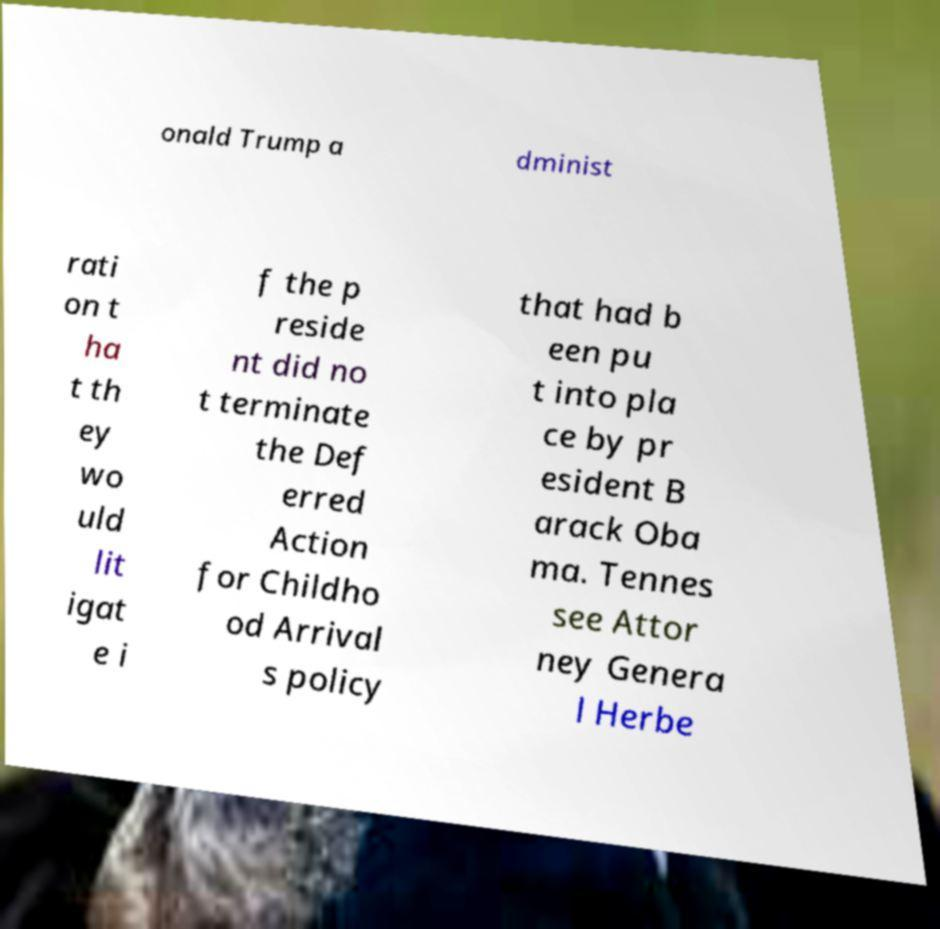Please identify and transcribe the text found in this image. onald Trump a dminist rati on t ha t th ey wo uld lit igat e i f the p reside nt did no t terminate the Def erred Action for Childho od Arrival s policy that had b een pu t into pla ce by pr esident B arack Oba ma. Tennes see Attor ney Genera l Herbe 